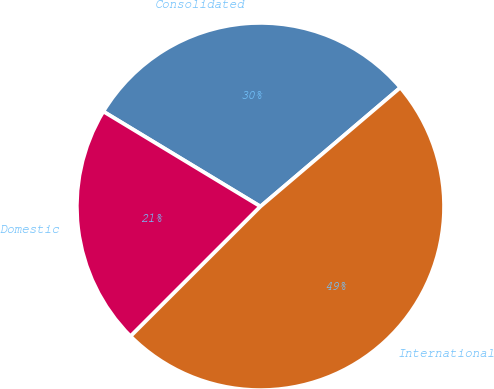<chart> <loc_0><loc_0><loc_500><loc_500><pie_chart><fcel>Consolidated<fcel>Domestic<fcel>International<nl><fcel>30.13%<fcel>21.15%<fcel>48.72%<nl></chart> 